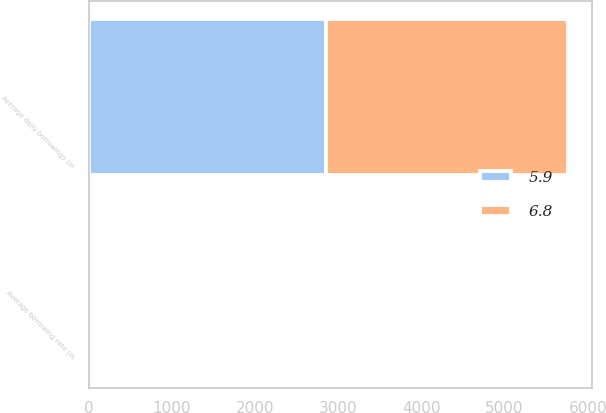<chart> <loc_0><loc_0><loc_500><loc_500><stacked_bar_chart><ecel><fcel>Average daily borrowings (in<fcel>Average borrowing rate (in<nl><fcel>5.9<fcel>2857<fcel>6.8<nl><fcel>6.8<fcel>2900<fcel>5.9<nl></chart> 